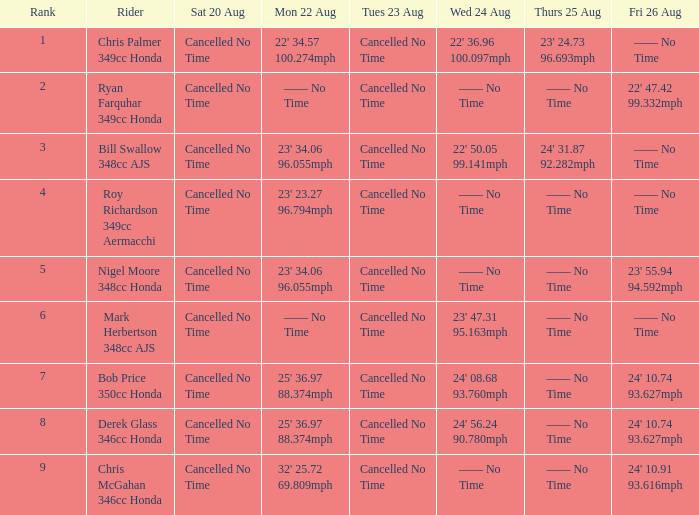What is every entry for Friday August 26 if the entry for Monday August 22 is 32' 25.72 69.809mph? 24' 10.91 93.616mph. 